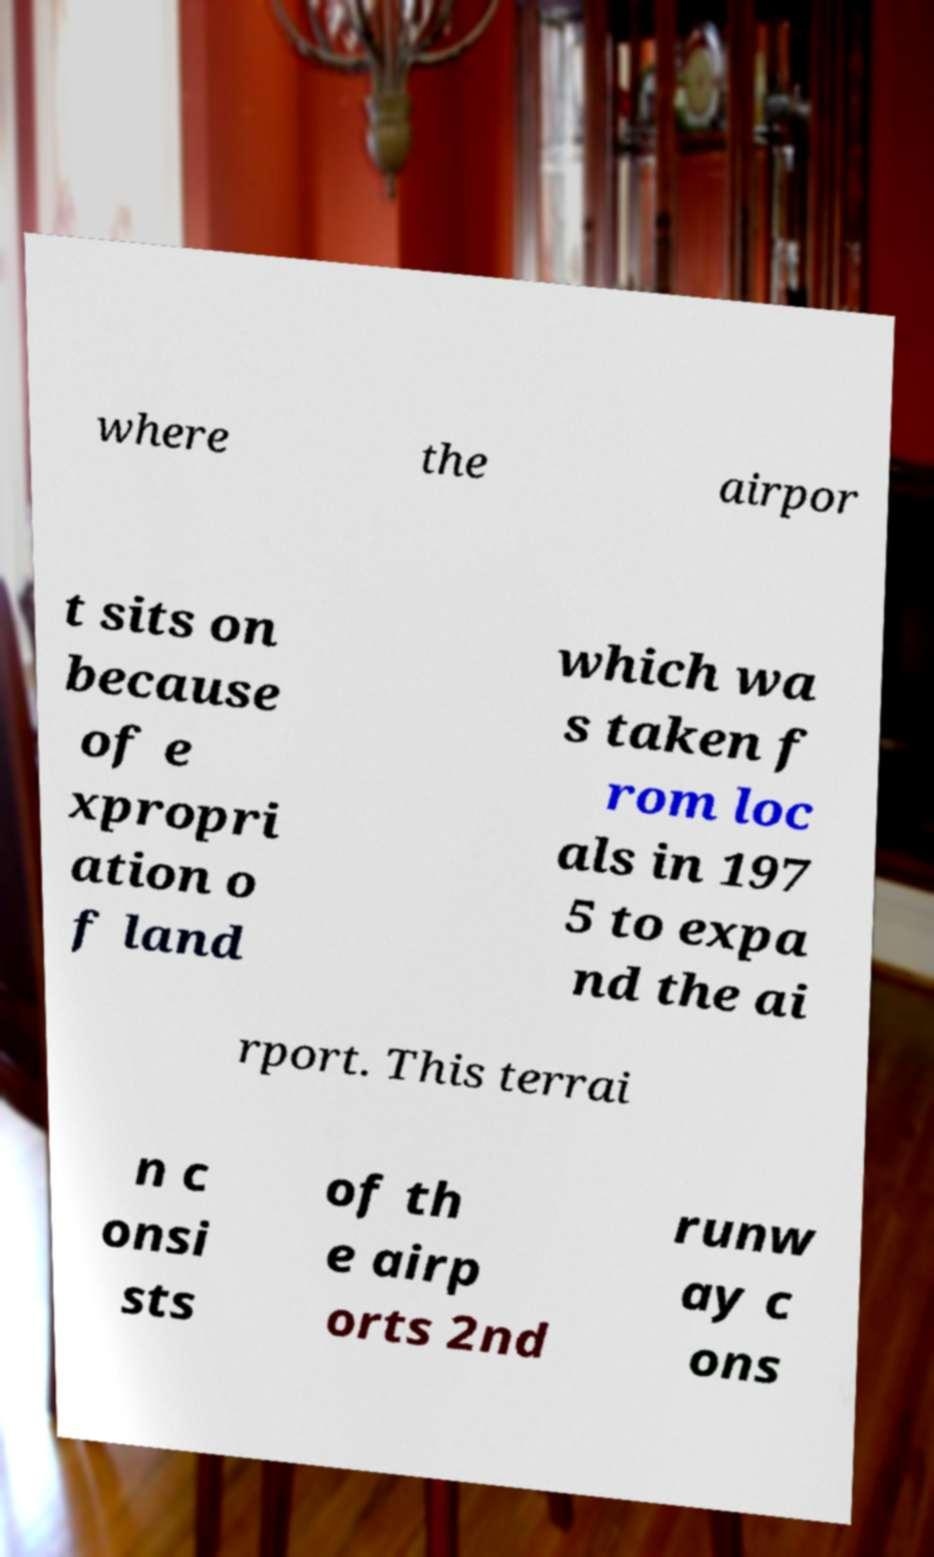Could you assist in decoding the text presented in this image and type it out clearly? where the airpor t sits on because of e xpropri ation o f land which wa s taken f rom loc als in 197 5 to expa nd the ai rport. This terrai n c onsi sts of th e airp orts 2nd runw ay c ons 